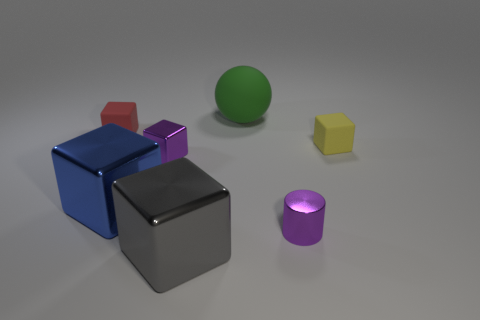Subtract 2 cubes. How many cubes are left? 3 Subtract all green blocks. Subtract all green balls. How many blocks are left? 5 Add 2 large brown things. How many objects exist? 9 Subtract all cylinders. How many objects are left? 6 Subtract all big yellow rubber objects. Subtract all tiny objects. How many objects are left? 3 Add 1 red rubber blocks. How many red rubber blocks are left? 2 Add 7 matte objects. How many matte objects exist? 10 Subtract 1 blue cubes. How many objects are left? 6 